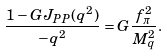Convert formula to latex. <formula><loc_0><loc_0><loc_500><loc_500>\frac { 1 - G J _ { P P } ( q ^ { 2 } ) } { - q ^ { 2 } } = G \frac { f _ { \pi } ^ { 2 } } { M _ { q } ^ { 2 } } .</formula> 